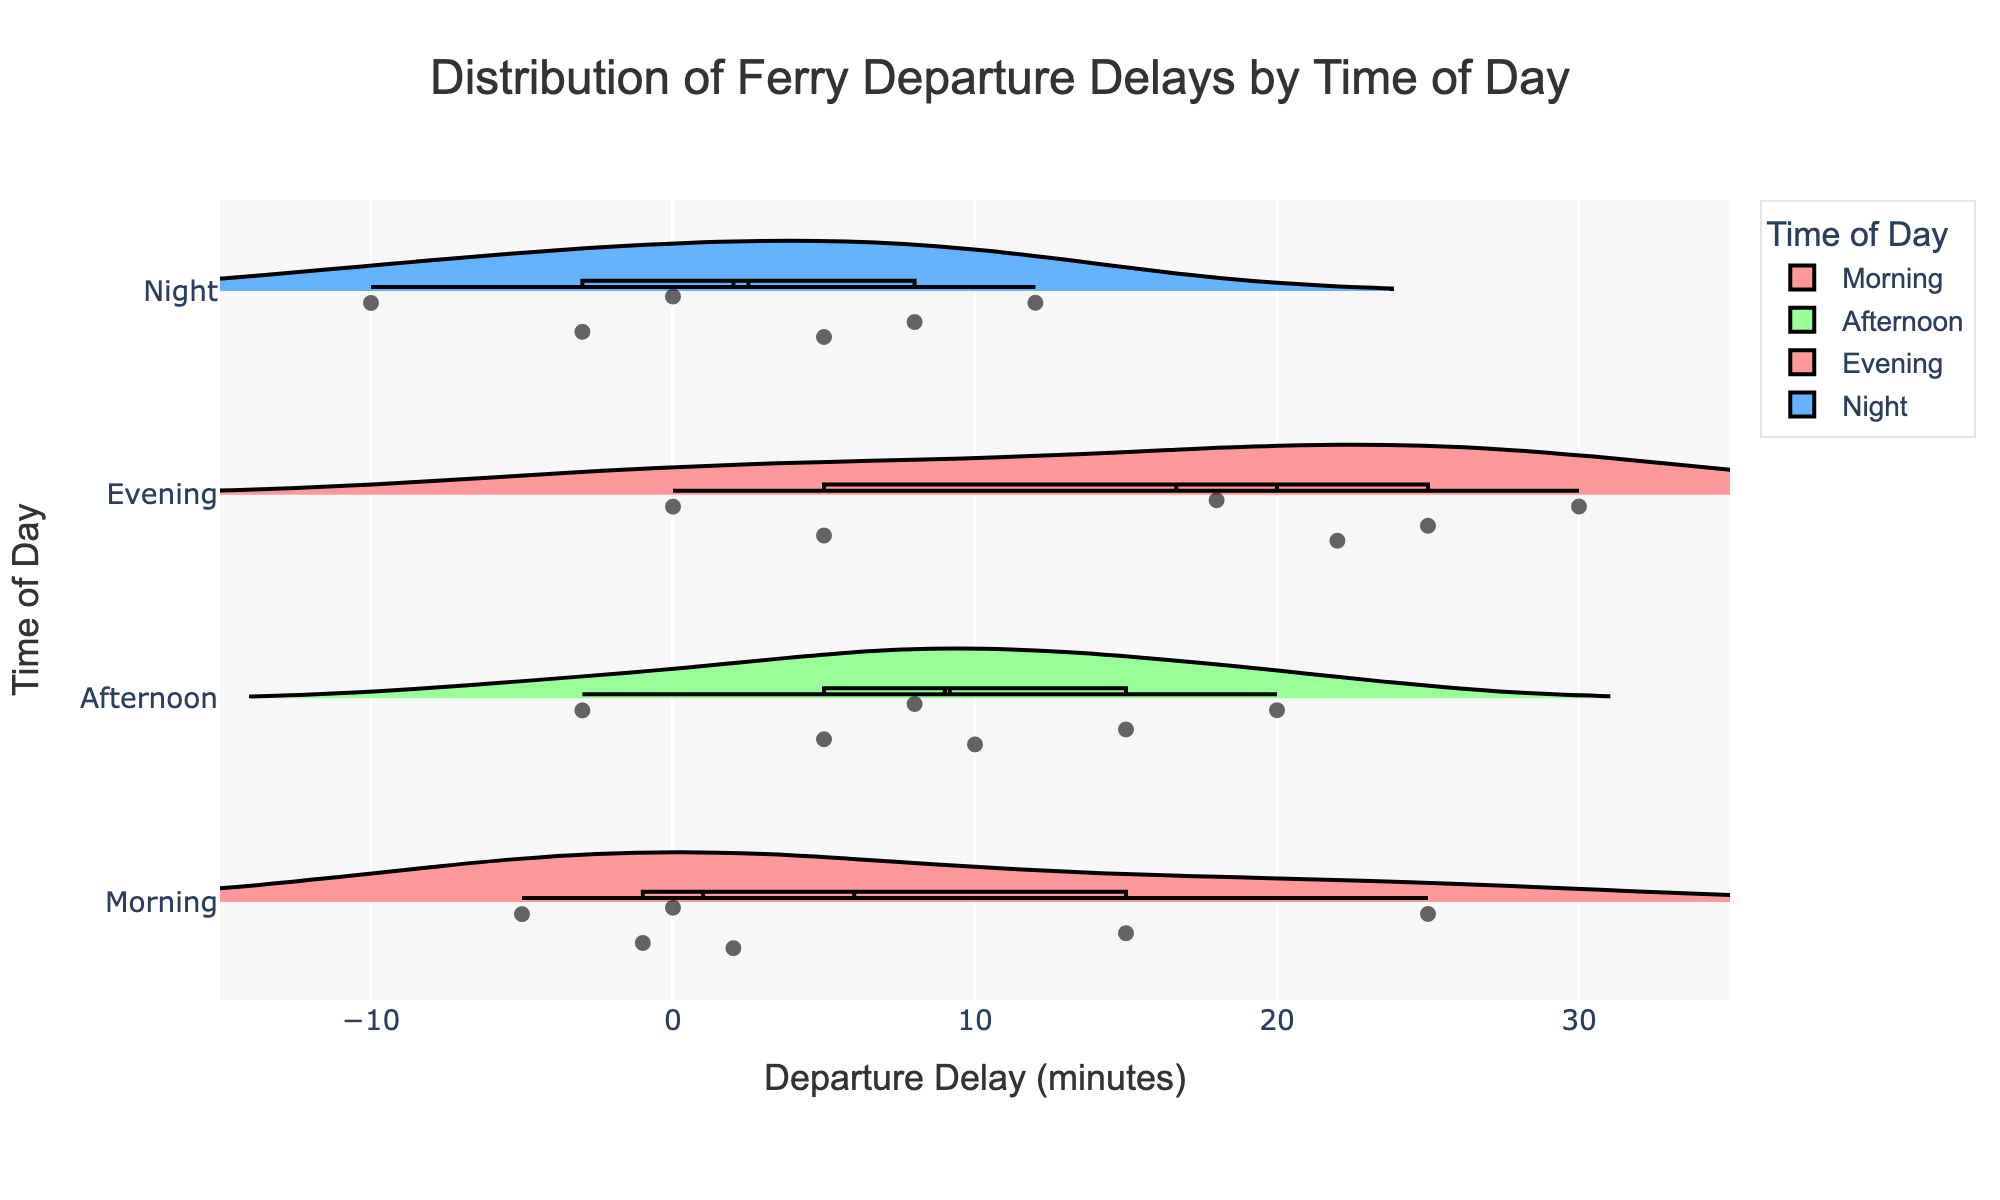What's the title of the figure? The title is usually found at the top center of the plot and is intended to summarize the content of the figure. In this case, it's "Distribution of Ferry Departure Delays by Time of Day".
Answer: "Distribution of Ferry Departure Delays by Time of Day" What is the x-axis title of the figure? The x-axis title is typically found below the horizontal axis. In this figure, it states "Departure Delay (minutes)".
Answer: "Departure Delay (minutes)" How many times of day categories are displayed in the figure? Each violin plot corresponds to a different "time of day" category. By counting the number of distinct violin plots, we see there are four categories: Morning, Afternoon, Evening, and Night.
Answer: 4 Which time of day shows the most consistent ferry departure delays? Consistency can be interpreted as the narrowest spread of data points. By observing the spread of the violin plots, "Night" has the narrowest spread around its mean value.
Answer: Night What is the maximum departure delay recorded in the Evening category? In the Evening category, the violin plot reaches up to a point near 30 minutes. This represents the maximum delay for that time of day.
Answer: 30 minutes Which time of day has the largest range of departure delays? The range can be determined by the difference between the maximum and minimum values in each violin plot. The "Morning" category has the largest range, starting from -5 up to 25.
Answer: Morning During which time of day do the ferries have the earliest recorded departure (earliest negative delay)? The earliest recorded departure is determined by the most negative value. By observing the violin plots, the Night category shows the earliest recorded departure with a delay of -10 minutes.
Answer: Night What is the average departure delay for the Afternoon category based on the mean line? The mean line is highlighted within each violin plot, and in the Afternoon category, it shows around 9 minutes.
Answer: 9 minutes Which time of day includes departure delays that occur before the scheduled time (negative delays)? Negative delays can be observed by the portion of the violin plot extending into the negative x-axis. "Morning," "Afternoon," and "Night" all include negative delays.
Answer: Morning, Afternoon, Night How are outlier points represented in the violin plots? Outlier points are represented using individual dots within the plots, which are included with some jitter for visibility. Each time of day category will have these points scattering visibly.
Answer: Individual dots with jitter 